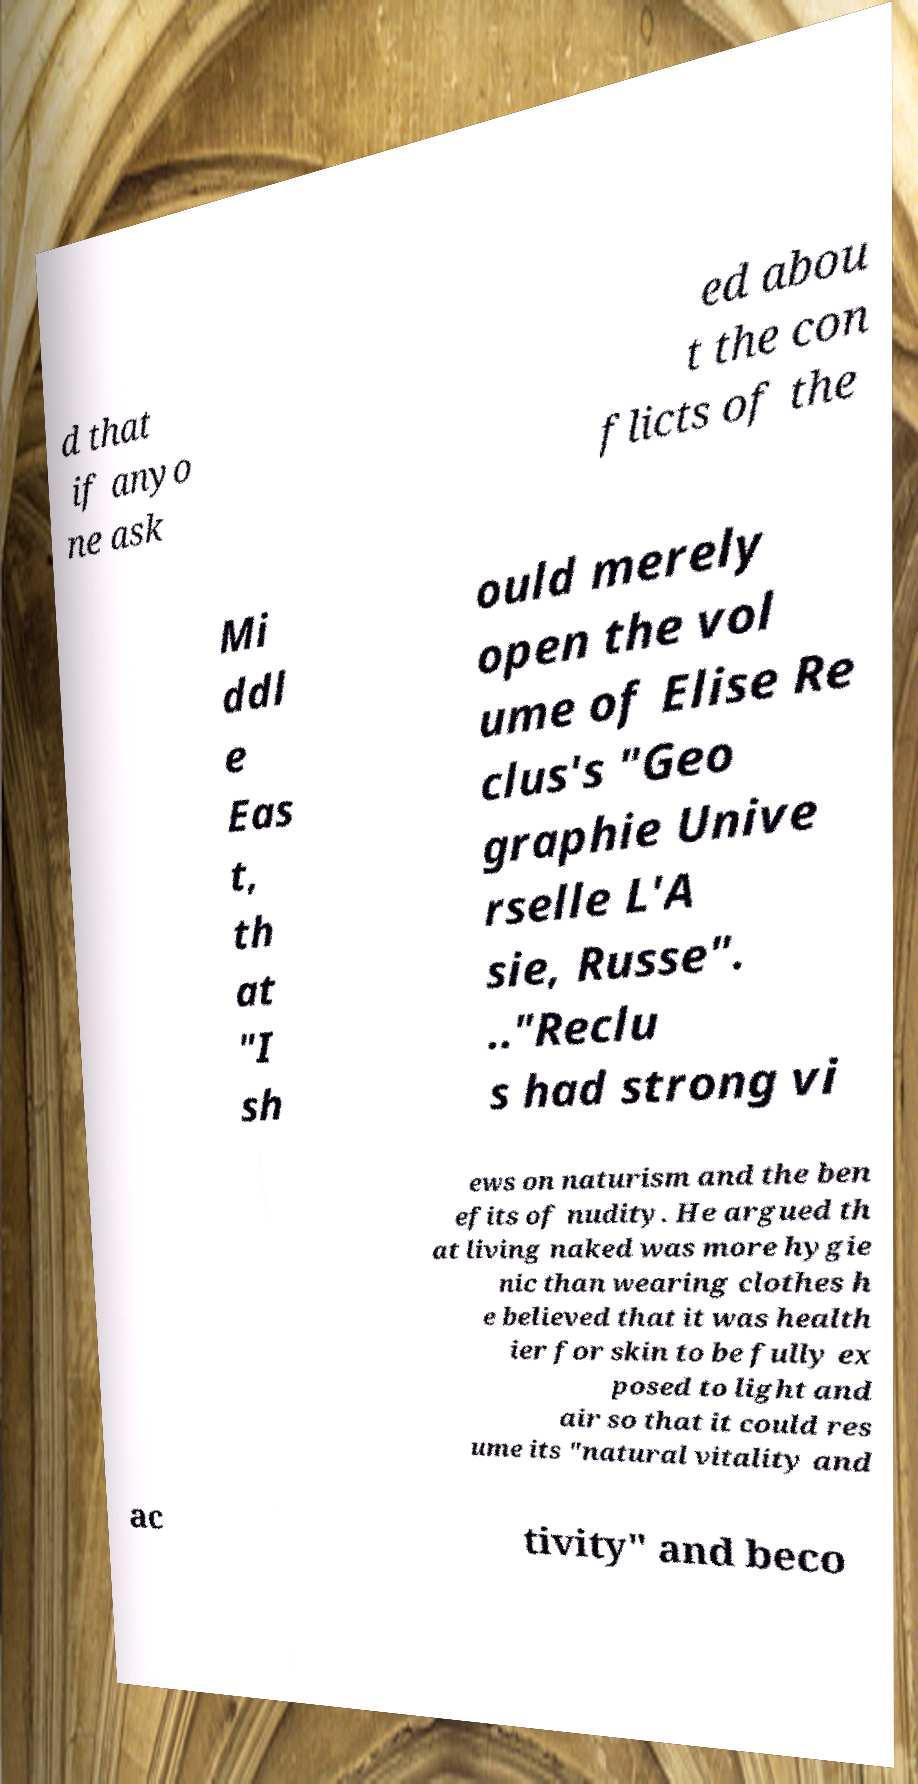What messages or text are displayed in this image? I need them in a readable, typed format. d that if anyo ne ask ed abou t the con flicts of the Mi ddl e Eas t, th at "I sh ould merely open the vol ume of Elise Re clus's "Geo graphie Unive rselle L'A sie, Russe". .."Reclu s had strong vi ews on naturism and the ben efits of nudity. He argued th at living naked was more hygie nic than wearing clothes h e believed that it was health ier for skin to be fully ex posed to light and air so that it could res ume its "natural vitality and ac tivity" and beco 